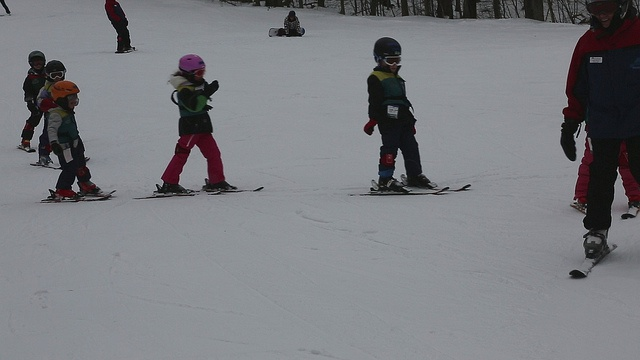Describe the objects in this image and their specific colors. I can see people in black, gray, darkgray, and maroon tones, people in black, darkgray, gray, and darkgreen tones, people in black, gray, and maroon tones, people in black, maroon, gray, and purple tones, and people in black, darkgray, and gray tones in this image. 